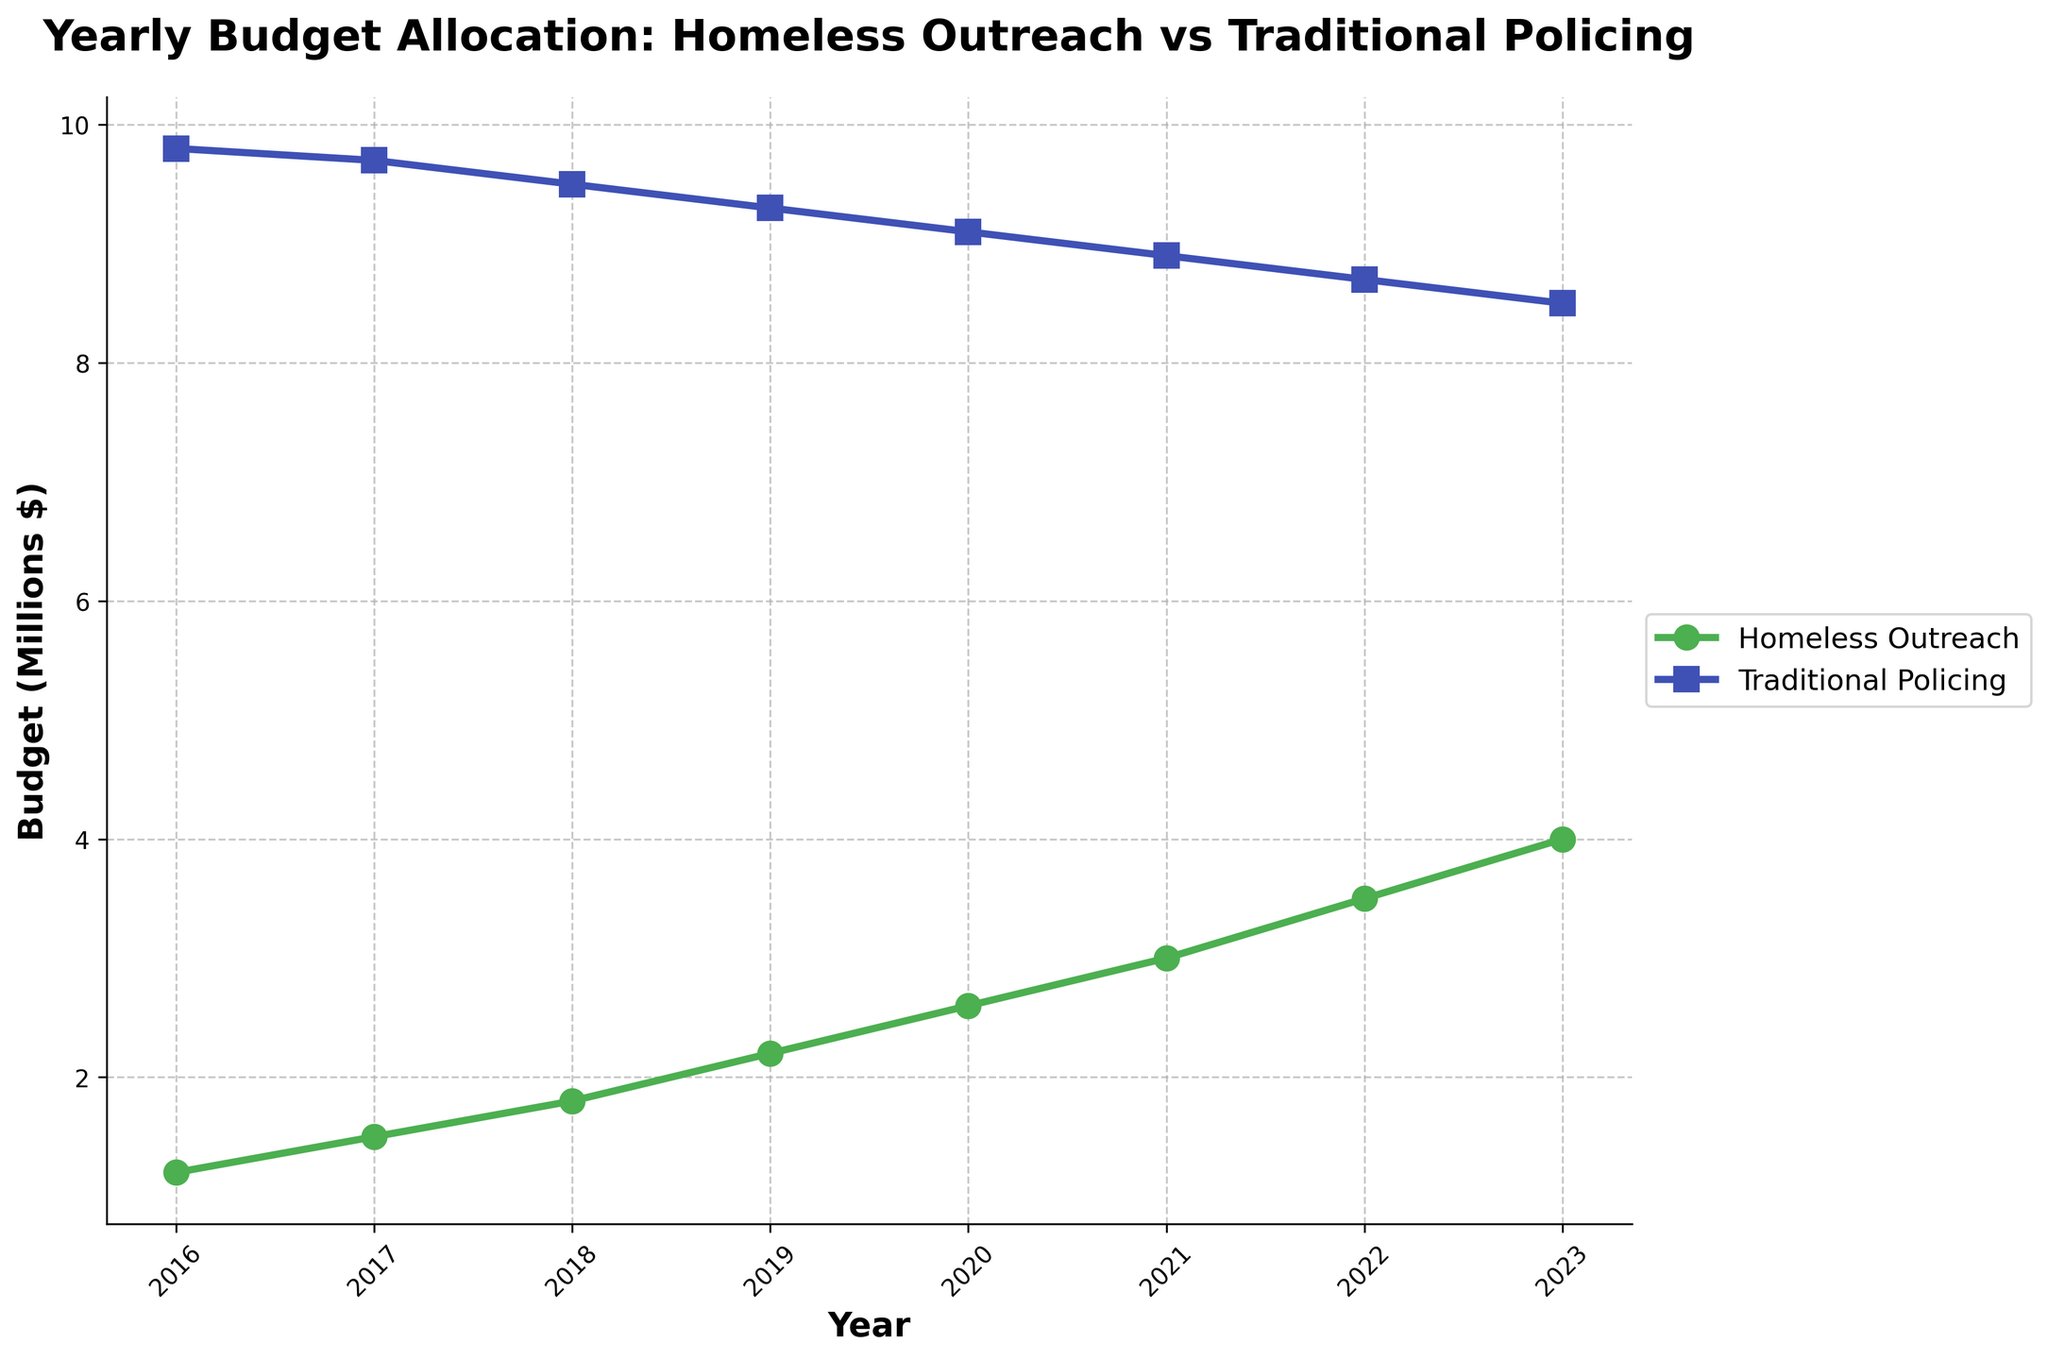What is the overall trend of the Homeless Outreach Budget from 2016 to 2023? By observing the green line representing the Homeless Outreach Budget, we see it consistently increases each year, indicating a positive trend.
Answer: Increasing How much did the Homeless Outreach Budget increase from 2016 to 2023? In 2016, the Homeless Outreach Budget was 1.2 million dollars. By 2023, it increased to 4 million dollars. The difference is 4 million - 1.2 million.
Answer: 2.8 million dollars In which year did the Homeless Outreach Budget exceed 3 million dollars? The green line representing the Homeless Outreach Budget reaches above 3 million dollars in the year 2021.
Answer: 2021 Which budget had a higher amount allocated in 2018, Homeless Outreach or Traditional Policing? By comparing the heights of the green and blue lines in 2018, the Traditional Policing Budget was higher.
Answer: Traditional Policing By how much did the Traditional Policing Budget decrease from 2016 to 2023? The Traditional Policing Budget was 9.8 million dollars in 2016 and 8.5 million dollars in 2023. The difference is 9.8 million - 8.5 million.
Answer: 1.3 million dollars What is the combined budget for both programs in 2020? The Homeless Outreach Budget in 2020 was 2.6 million dollars and the Traditional Policing Budget was 9.1 million dollars. The combined budget is 2.6 million + 9.1 million.
Answer: 11.7 million dollars Which year had the smallest gap between the two budget allocations? The gap is the smallest when the height difference between the blue and green lines is minimal. In 2023, the gap is smallest.
Answer: 2023 What is the average yearly increase in the Homeless Outreach Budget from 2016 to 2023? We take the total increase of 2.8 million (from 1.2 million to 4 million) over 7 years. The average is 2.8 million divided by 7.
Answer: 0.4 million dollars per year What was the traditional policing budget in 2021 compared to the homeless outreach budget in the same year? The Traditional Policing Budget in 2021 was 8.9 million dollars, and the Homeless Outreach Budget was 3 million dollars. The Traditional Policing Budget was higher.
Answer: Traditional Policing Budget was higher Between which consecutive years did the Homeless Outreach Budget see the highest increase? Observing the green line for the largest upward jump, the budget saw the highest increase between 2020 and 2021, rising from 2.6 million to 3 million dollars.
Answer: 2020-2021 